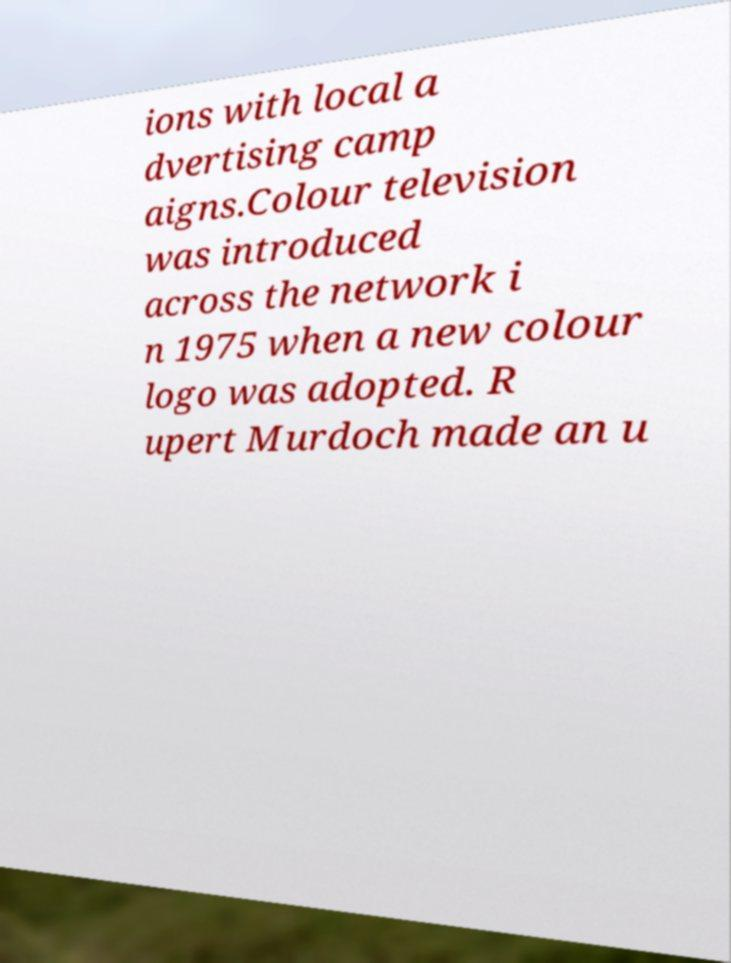There's text embedded in this image that I need extracted. Can you transcribe it verbatim? ions with local a dvertising camp aigns.Colour television was introduced across the network i n 1975 when a new colour logo was adopted. R upert Murdoch made an u 